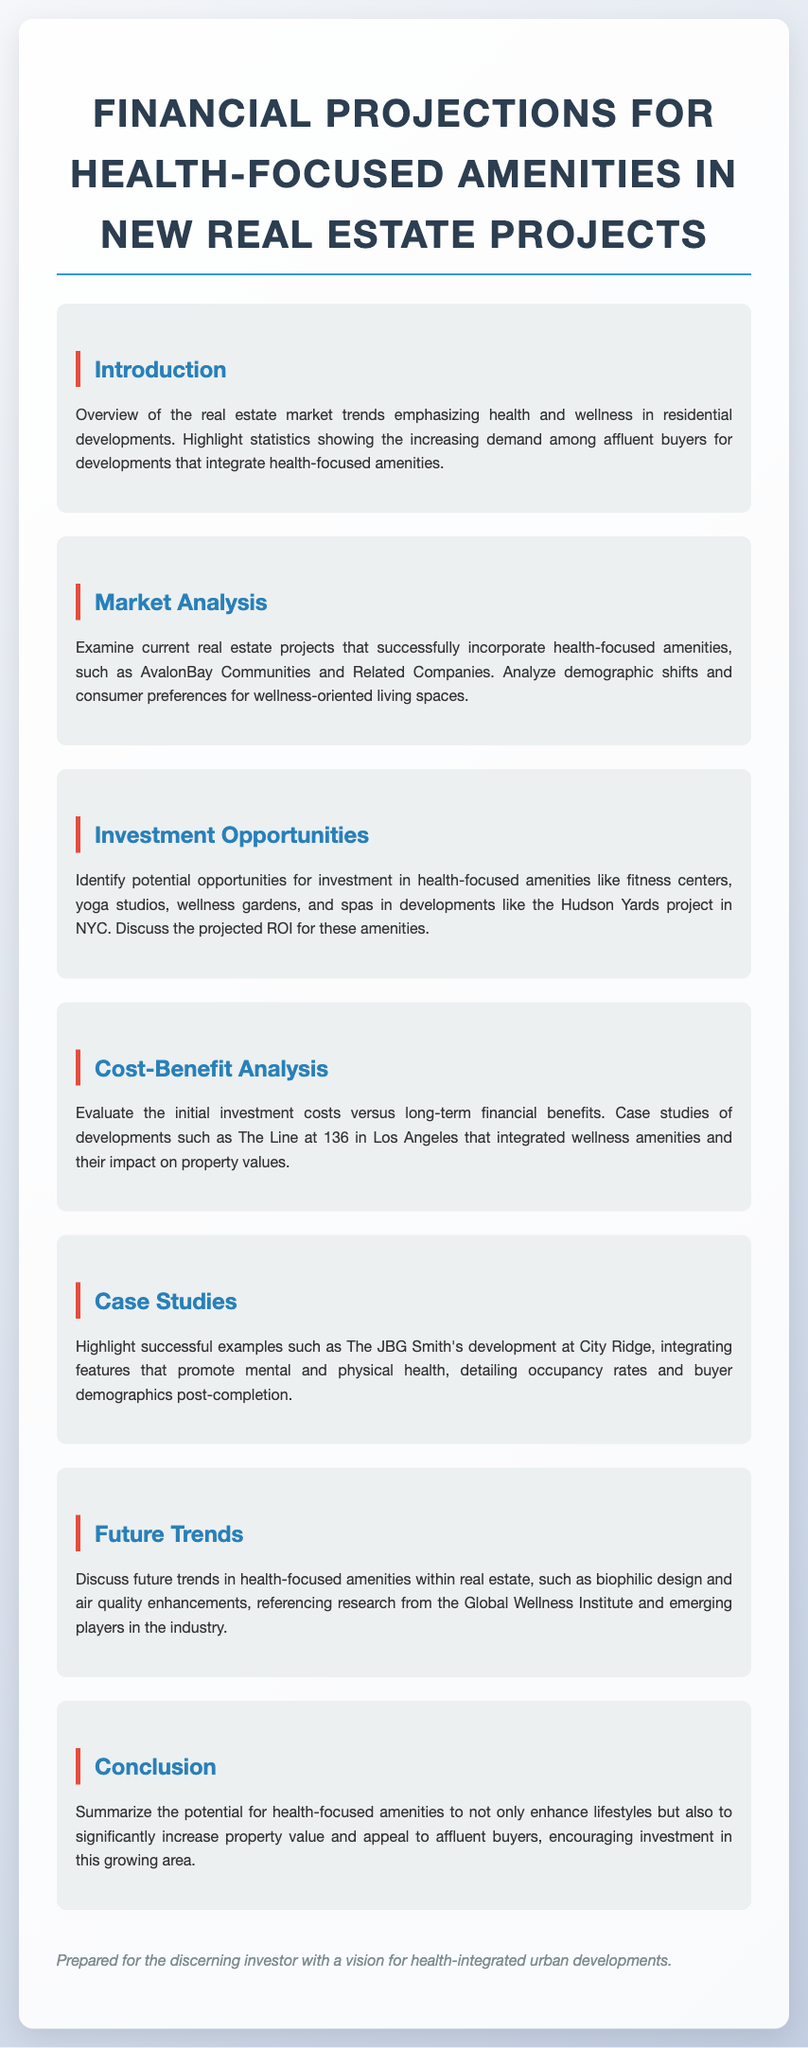What is the title of the document? The title of the document is stated at the top of the content section, summarizing the main topic of discussion.
Answer: Financial Projections for Health-Focused Amenities in New Real Estate Projects What market trends are highlighted in the introduction? The introduction outlines trends related to health and wellness, specifically emphasizing the demand among affluent buyers.
Answer: Health and wellness Which companies are mentioned in the market analysis? The market analysis discusses specific companies that successfully incorporate health-focused amenities within their projects.
Answer: AvalonBay Communities and Related Companies What are some examples of health-focused amenities listed in the investment opportunities? The investment opportunities section identifies specific types of amenities that could be integrated into real estate developments.
Answer: Fitness centers, yoga studios, wellness gardens, spas What case study is mentioned in the cost-benefit analysis? The cost-benefit analysis references a specific development that integrated wellness amenities successfully, showcasing its impact.
Answer: The Line at 136 What is a future trend mentioned for health-focused amenities? This section discusses emerging concepts and enhancements related to wellness, indicating a direction for future development.
Answer: Biophilic design What is the main conclusion regarding health-focused amenities? The conclusion summarizes the overall potential impact of health-focused amenities on property value and buyer appeal.
Answer: Increase property value What demographic is referenced in the case studies? The demographic information pertains to the type of buyers attracted to developments with health-oriented features.
Answer: Affluent buyers 